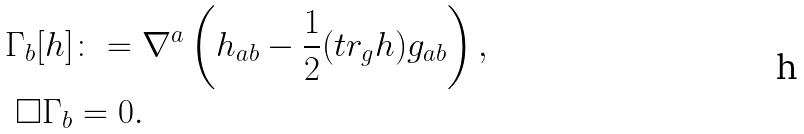Convert formula to latex. <formula><loc_0><loc_0><loc_500><loc_500>\Gamma _ { b } [ h ] & \colon = \nabla ^ { a } \left ( h _ { a b } - \frac { 1 } { 2 } ( t r _ { g } h ) g _ { a b } \right ) , \\ \Box \Gamma _ { b } & = 0 .</formula> 